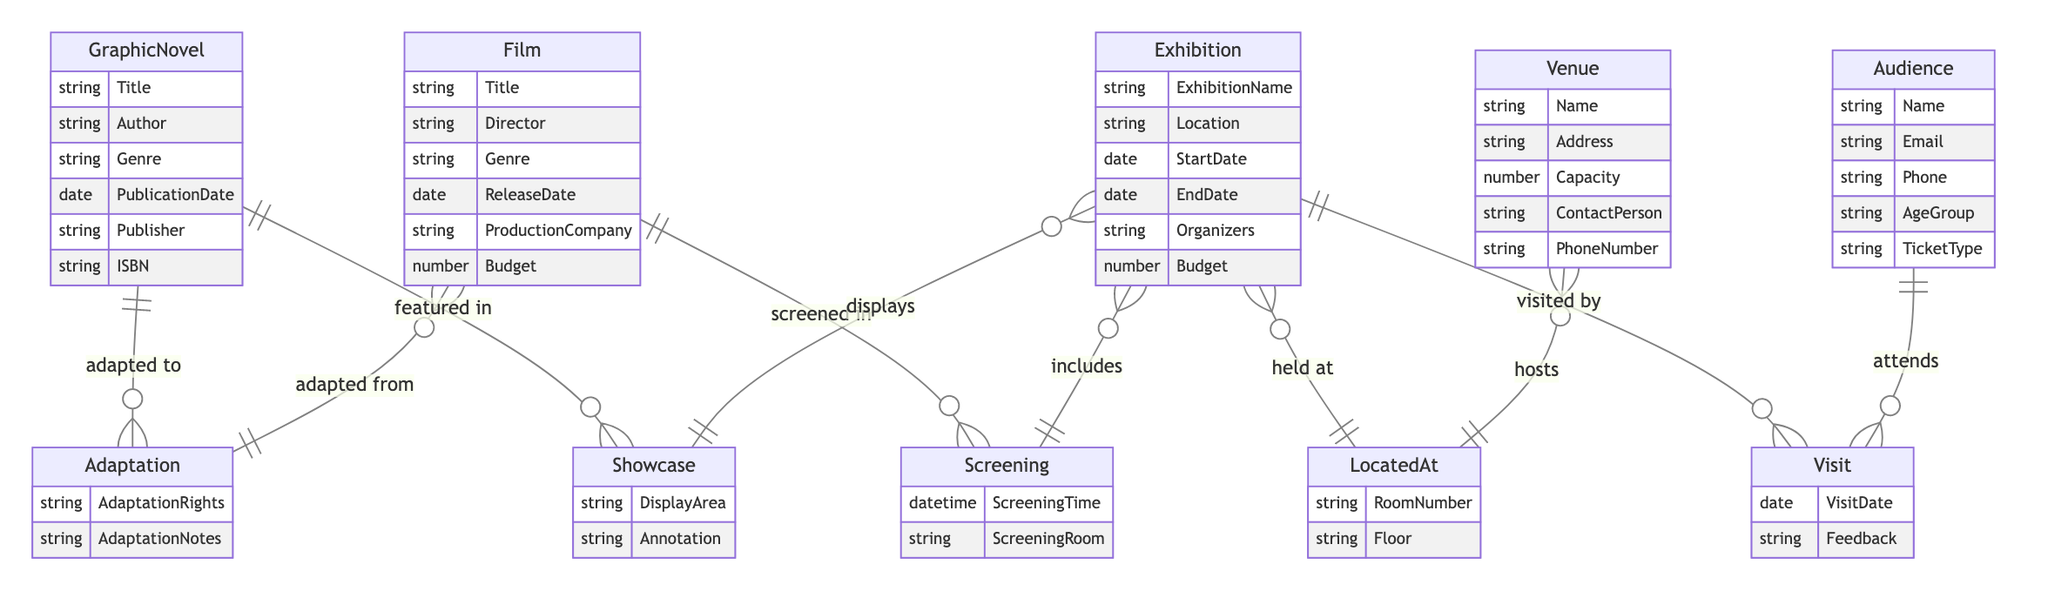What is the main relationship between GraphicNovel and Film? The main relationship between GraphicNovel and Film is the adaptation relationship, represented by the term "adapted to" in the diagram. This implies that a graphic novel can be adapted into a film.
Answer: adapted to How many attributes are associated with the Audience entity? The Audience entity has five attributes: Name, Email, Phone, AgeGroup, and TicketType. Counting these gives us a total of five attributes.
Answer: 5 What can you say about the screening of films in the exhibition? The relationship between Film and Exhibition is indicated by "screened in," which signifies that films are part of an exhibition and can be screened there.
Answer: screened in What is the role of the Venue in the Exhibition? The Venue is linked to the Exhibition through the relationship "hosts," which means that the venue acts as a host location for the exhibition events.
Answer: hosts How many entities are involved in the Visit relationship? The Visit relationship involves two entities: Audience and Exhibition. This is clear from the diagram, where this relationship connects these two entities directly.
Answer: 2 What attribute connects the Exhibition and Venue entities with location information? The RoomNumber and Floor attributes connect the Exhibition and Venue entities by providing specific information regarding where the exhibition is held within the venue.
Answer: RoomNumber, Floor How are GraphicNovels showcased in exhibitions? GraphicNovels are showcased in exhibitions through the "featured in" relationship, which indicates that graphic novels are displayed during the exhibition.
Answer: featured in What type of information can be recorded in the Visit relationship? The Visit relationship records VisitDate and Feedback, which allows for the tracking of when attendees visited and their opinions about the exhibition.
Answer: VisitDate, Feedback Which entity has a Budget attribute related to financial planning? Both the Exhibition and Film entities have a Budget attribute, indicating that there are financial considerations for both organizing exhibitions and producing films.
Answer: Exhibition, Film 